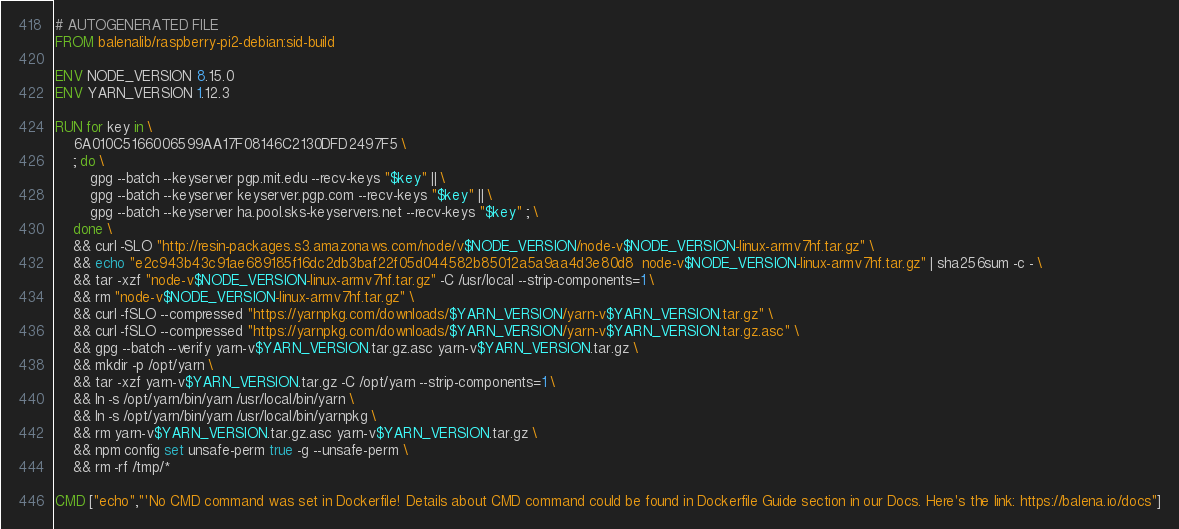<code> <loc_0><loc_0><loc_500><loc_500><_Dockerfile_># AUTOGENERATED FILE
FROM balenalib/raspberry-pi2-debian:sid-build

ENV NODE_VERSION 8.15.0
ENV YARN_VERSION 1.12.3

RUN for key in \
	6A010C5166006599AA17F08146C2130DFD2497F5 \
	; do \
		gpg --batch --keyserver pgp.mit.edu --recv-keys "$key" || \
		gpg --batch --keyserver keyserver.pgp.com --recv-keys "$key" || \
		gpg --batch --keyserver ha.pool.sks-keyservers.net --recv-keys "$key" ; \
	done \
	&& curl -SLO "http://resin-packages.s3.amazonaws.com/node/v$NODE_VERSION/node-v$NODE_VERSION-linux-armv7hf.tar.gz" \
	&& echo "e2c943b43c91ae689185f16dc2db3baf22f05d044582b85012a5a9aa4d3e80d8  node-v$NODE_VERSION-linux-armv7hf.tar.gz" | sha256sum -c - \
	&& tar -xzf "node-v$NODE_VERSION-linux-armv7hf.tar.gz" -C /usr/local --strip-components=1 \
	&& rm "node-v$NODE_VERSION-linux-armv7hf.tar.gz" \
	&& curl -fSLO --compressed "https://yarnpkg.com/downloads/$YARN_VERSION/yarn-v$YARN_VERSION.tar.gz" \
	&& curl -fSLO --compressed "https://yarnpkg.com/downloads/$YARN_VERSION/yarn-v$YARN_VERSION.tar.gz.asc" \
	&& gpg --batch --verify yarn-v$YARN_VERSION.tar.gz.asc yarn-v$YARN_VERSION.tar.gz \
	&& mkdir -p /opt/yarn \
	&& tar -xzf yarn-v$YARN_VERSION.tar.gz -C /opt/yarn --strip-components=1 \
	&& ln -s /opt/yarn/bin/yarn /usr/local/bin/yarn \
	&& ln -s /opt/yarn/bin/yarn /usr/local/bin/yarnpkg \
	&& rm yarn-v$YARN_VERSION.tar.gz.asc yarn-v$YARN_VERSION.tar.gz \
	&& npm config set unsafe-perm true -g --unsafe-perm \
	&& rm -rf /tmp/*

CMD ["echo","'No CMD command was set in Dockerfile! Details about CMD command could be found in Dockerfile Guide section in our Docs. Here's the link: https://balena.io/docs"]</code> 